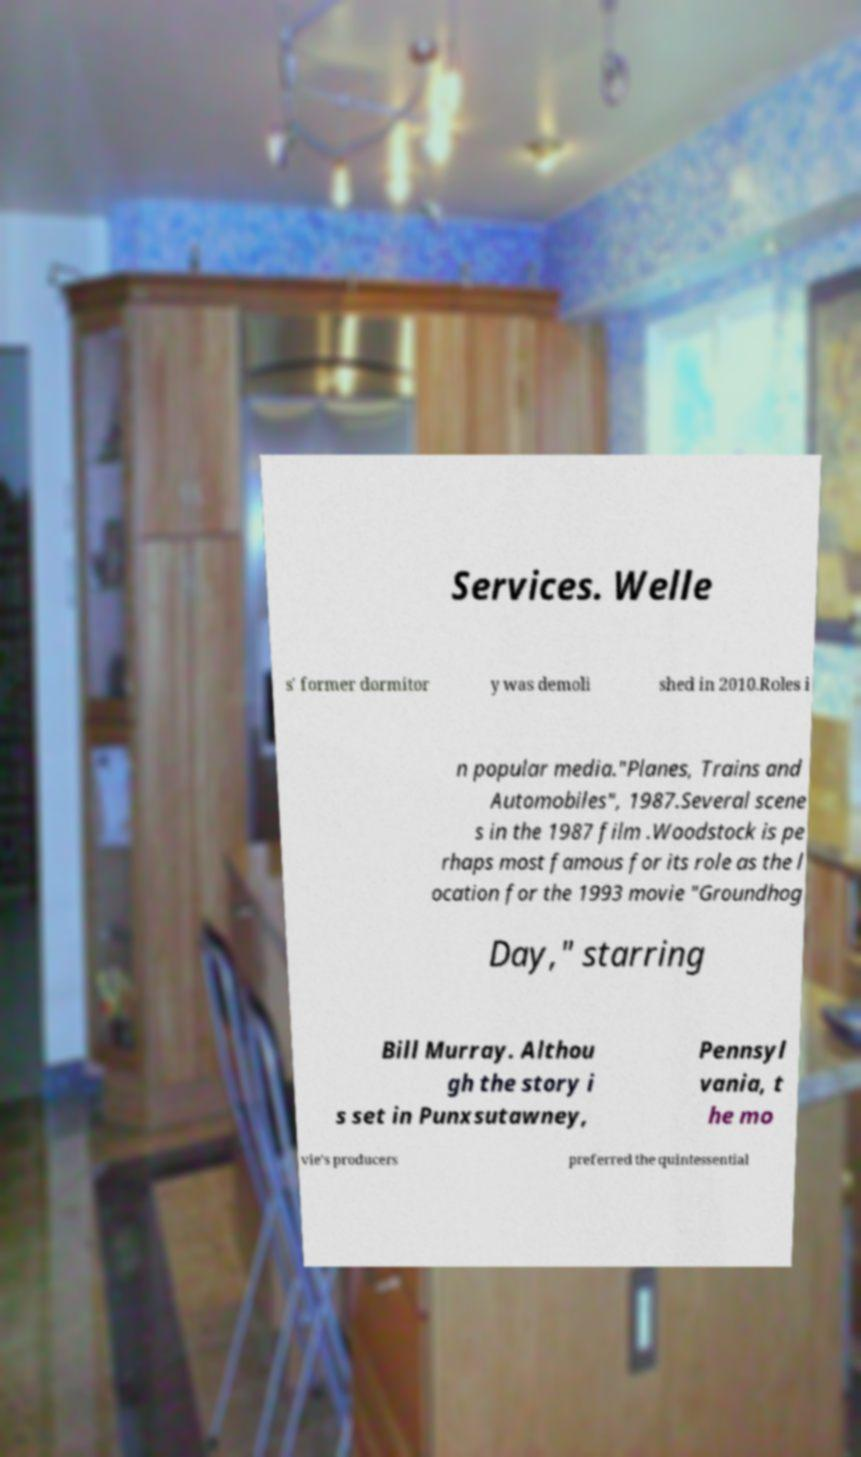I need the written content from this picture converted into text. Can you do that? Services. Welle s' former dormitor y was demoli shed in 2010.Roles i n popular media."Planes, Trains and Automobiles", 1987.Several scene s in the 1987 film .Woodstock is pe rhaps most famous for its role as the l ocation for the 1993 movie "Groundhog Day," starring Bill Murray. Althou gh the story i s set in Punxsutawney, Pennsyl vania, t he mo vie's producers preferred the quintessential 